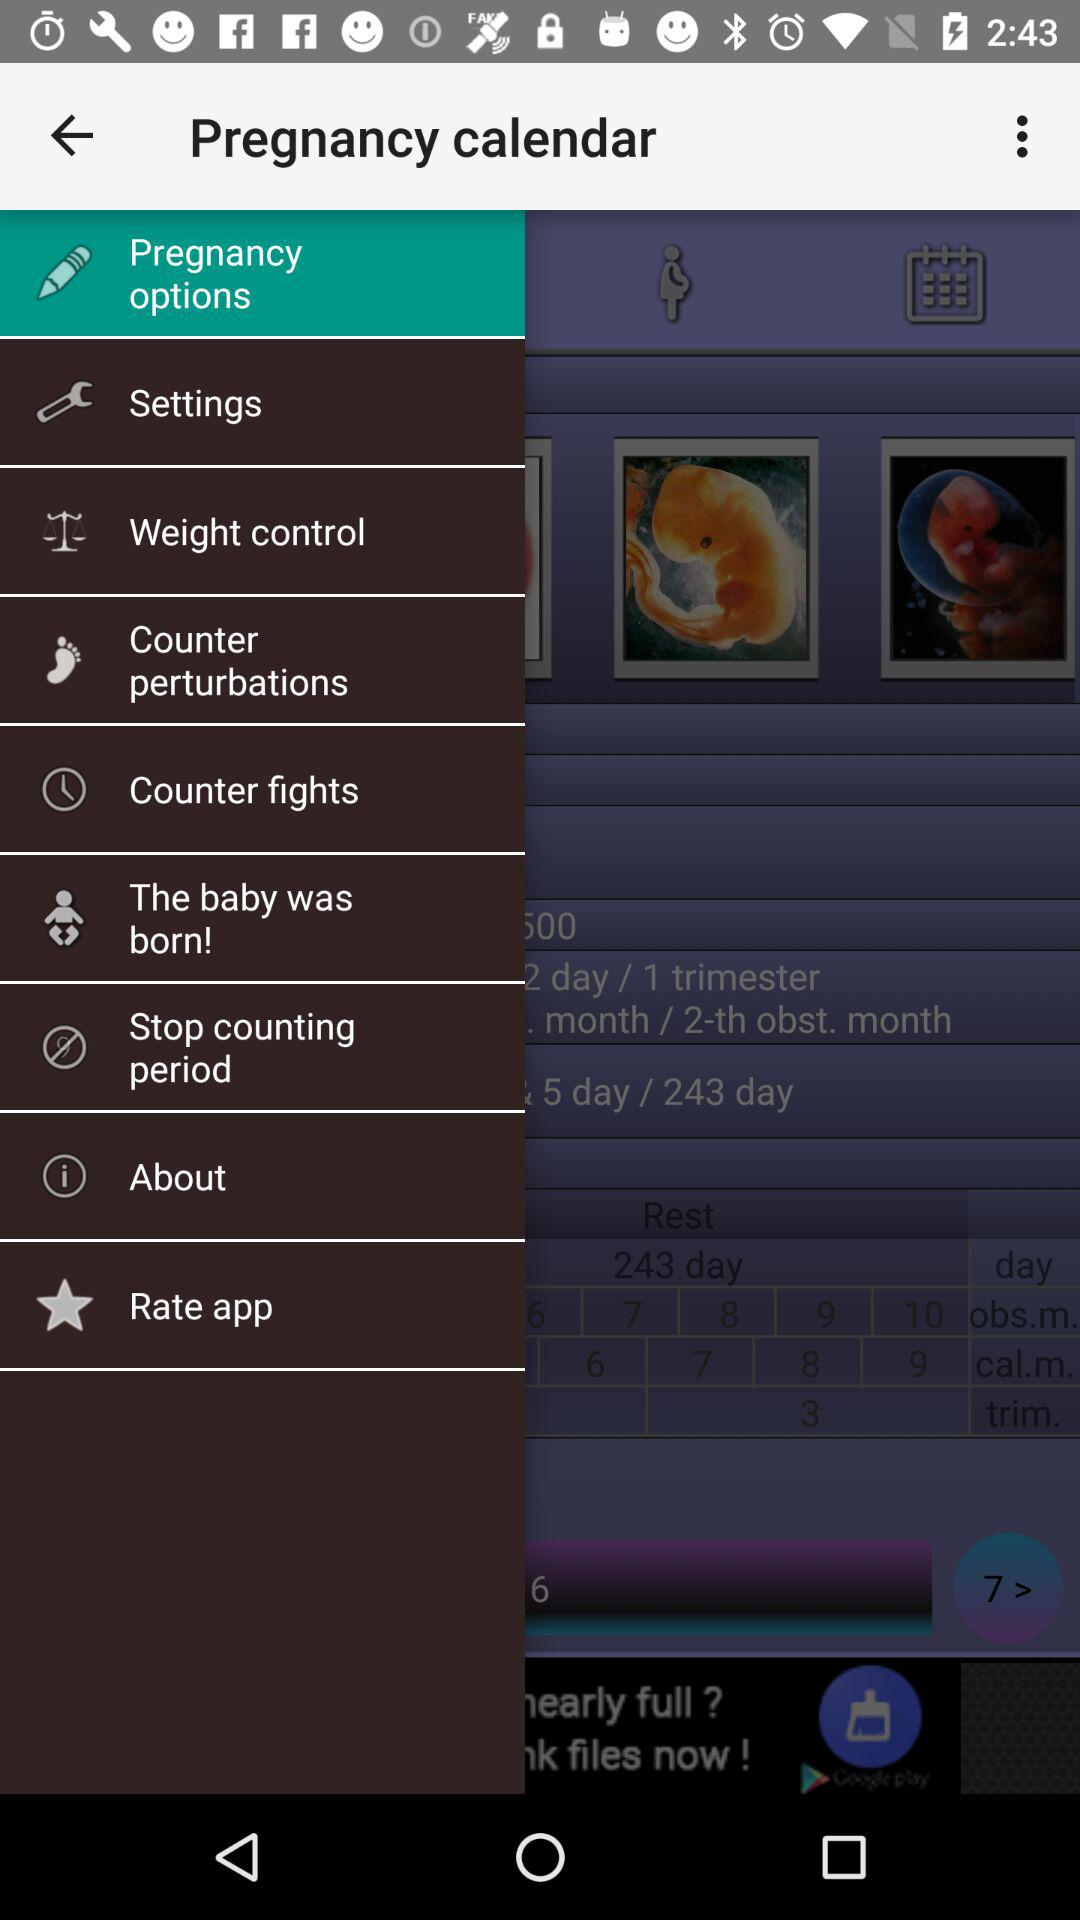How many people have rated the application?
When the provided information is insufficient, respond with <no answer>. <no answer> 